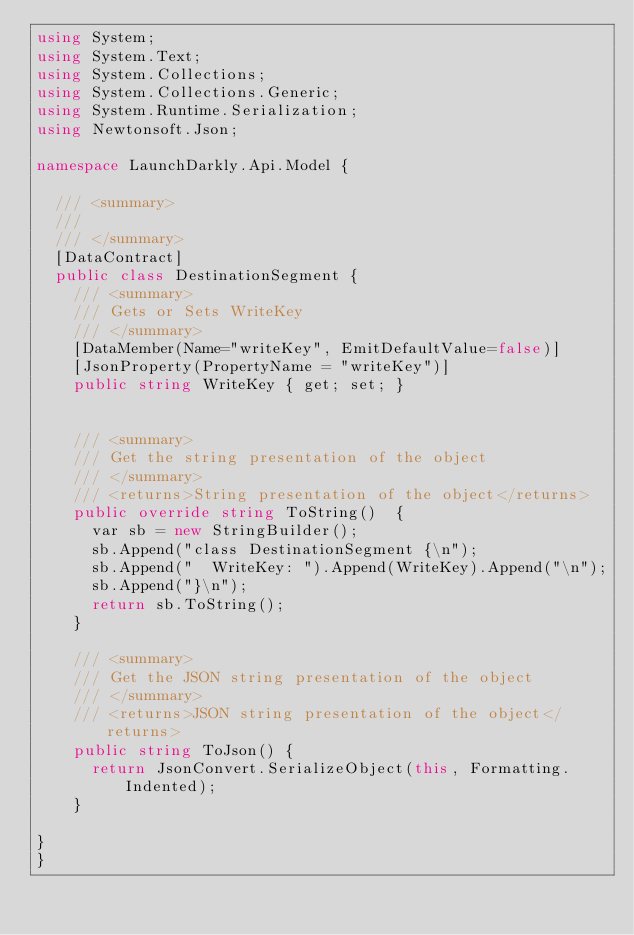<code> <loc_0><loc_0><loc_500><loc_500><_C#_>using System;
using System.Text;
using System.Collections;
using System.Collections.Generic;
using System.Runtime.Serialization;
using Newtonsoft.Json;

namespace LaunchDarkly.Api.Model {

  /// <summary>
  /// 
  /// </summary>
  [DataContract]
  public class DestinationSegment {
    /// <summary>
    /// Gets or Sets WriteKey
    /// </summary>
    [DataMember(Name="writeKey", EmitDefaultValue=false)]
    [JsonProperty(PropertyName = "writeKey")]
    public string WriteKey { get; set; }


    /// <summary>
    /// Get the string presentation of the object
    /// </summary>
    /// <returns>String presentation of the object</returns>
    public override string ToString()  {
      var sb = new StringBuilder();
      sb.Append("class DestinationSegment {\n");
      sb.Append("  WriteKey: ").Append(WriteKey).Append("\n");
      sb.Append("}\n");
      return sb.ToString();
    }

    /// <summary>
    /// Get the JSON string presentation of the object
    /// </summary>
    /// <returns>JSON string presentation of the object</returns>
    public string ToJson() {
      return JsonConvert.SerializeObject(this, Formatting.Indented);
    }

}
}
</code> 